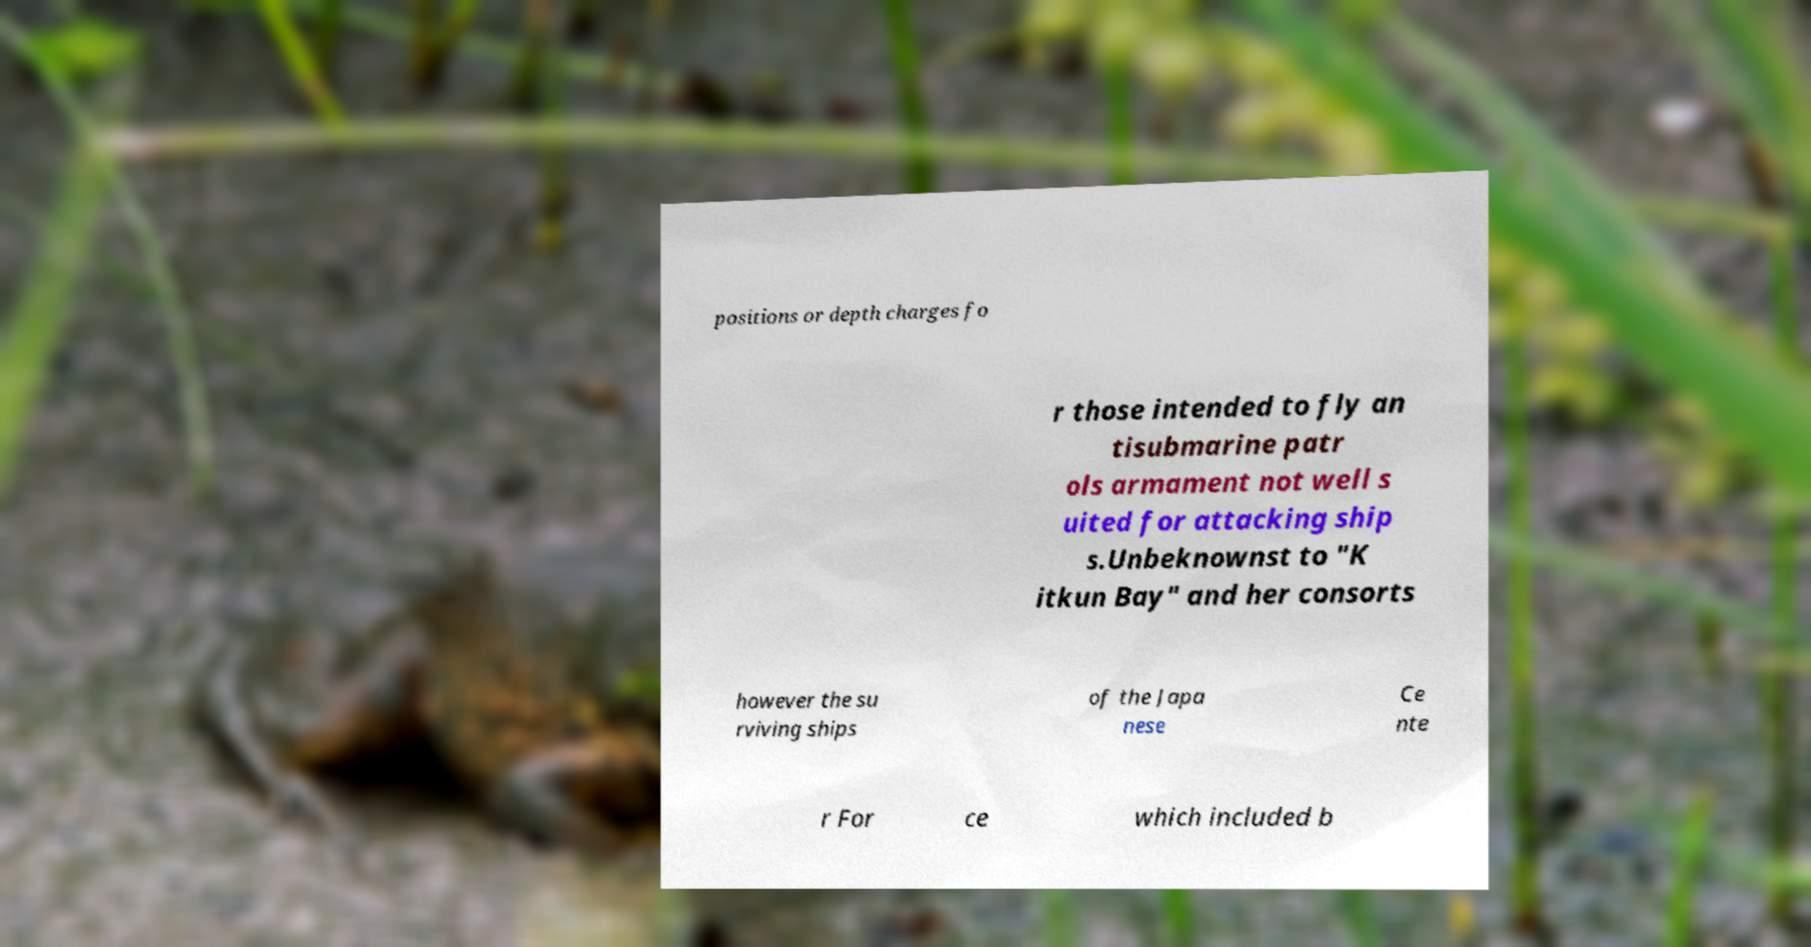Could you extract and type out the text from this image? positions or depth charges fo r those intended to fly an tisubmarine patr ols armament not well s uited for attacking ship s.Unbeknownst to "K itkun Bay" and her consorts however the su rviving ships of the Japa nese Ce nte r For ce which included b 